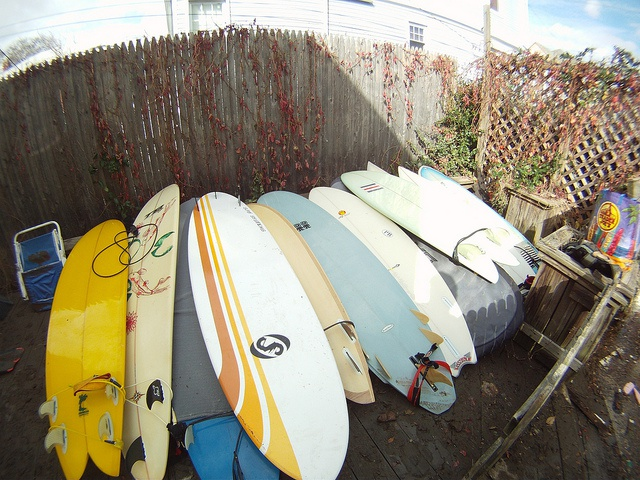Describe the objects in this image and their specific colors. I can see surfboard in lightgray, white, gold, tan, and orange tones, surfboard in lightgray, gold, and olive tones, surfboard in lightgray, lightblue, darkgray, and gray tones, surfboard in lightgray, beige, tan, and black tones, and surfboard in lightgray, gray, teal, blue, and black tones in this image. 